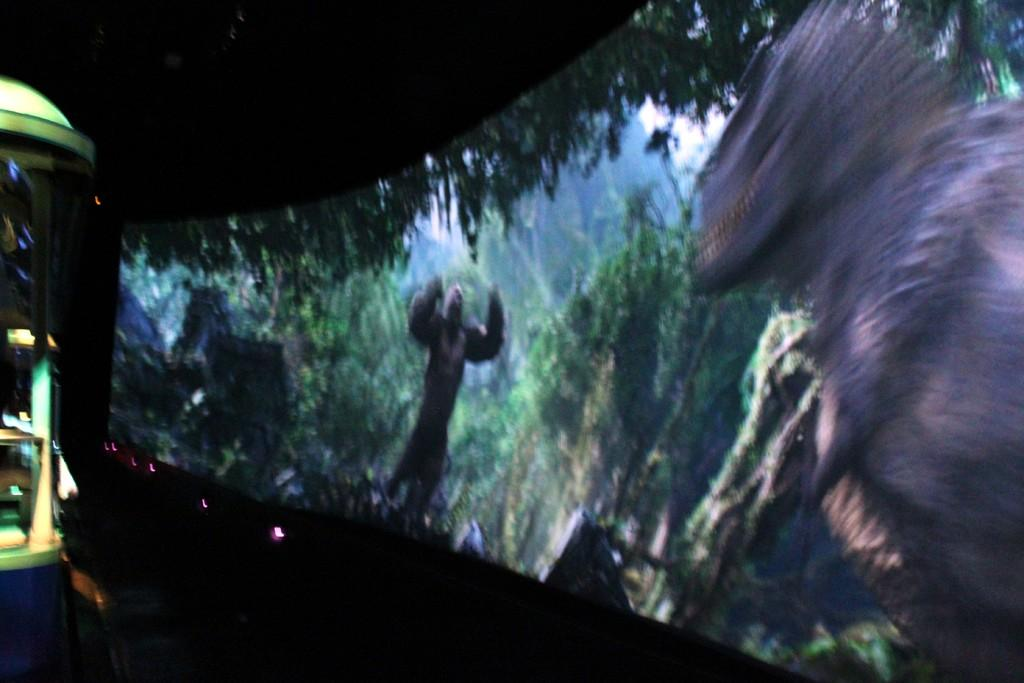What is the main subject of the image? There is a screen in the image. What can be seen on the screen? There are animals, trees, and sky visible on the screen. Can you describe the object on the left side of the image? There is an object on the left side of the image, but its details are not clear from the provided facts. What is located at the bottom of the image? There is a plant at the bottom of the image. What type of jellyfish can be seen swimming in the sky on the screen? There are no jellyfish visible on the screen; it features animals, trees, and sky, but no jellyfish. How does the taste of the plant at the bottom of the image compare to that of a ripe mango? The taste of the plant cannot be determined from the image, as taste is not a visual characteristic. 